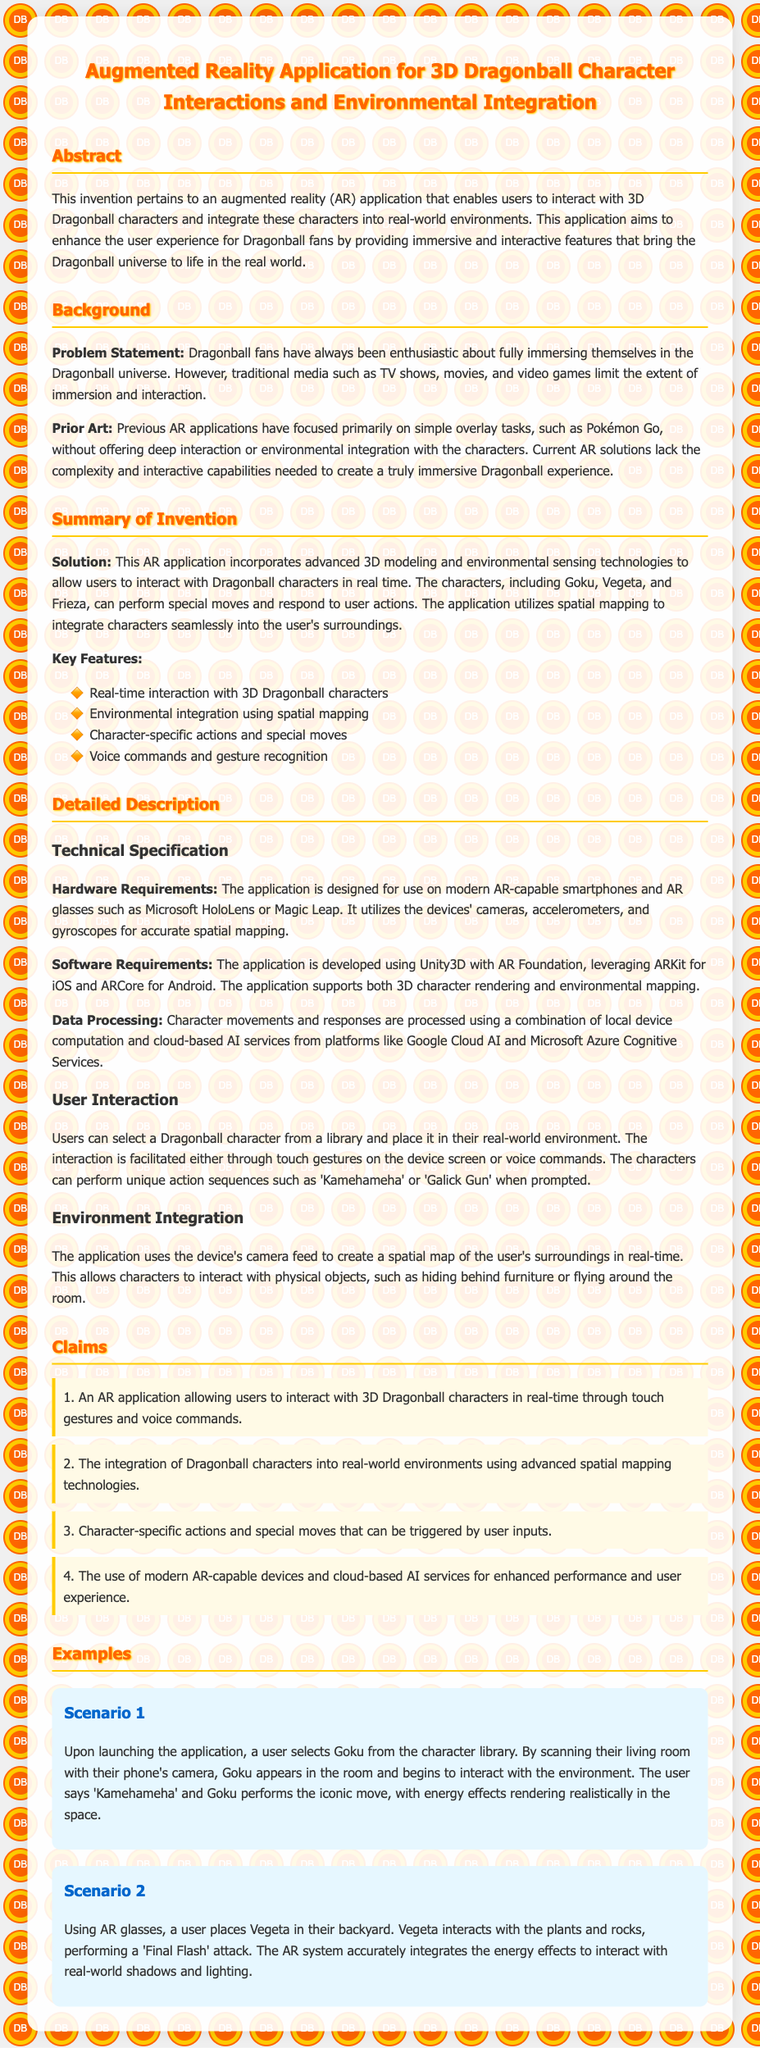What is the title of the patent application? The title of the patent application summarizing its purpose is prominently displayed at the top of the document.
Answer: Augmented Reality Application for 3D Dragonball Character Interactions and Environmental Integration Who are the characters mentioned in the summary of the invention? The summary lists specific Dragonball characters that users can interact with in the application, providing examples of known fan favorites.
Answer: Goku, Vegeta, Frieza What is the primary problem stated in the background section? The problem statement outlines the limitation of traditional media for Dragonball fans wanting immersive experiences.
Answer: Limited immersion and interaction Which technology is used for movement and responses processing? The document specifies the platforms utilized for processing character movements and responses, indicating the technological foundation of the application.
Answer: Cloud-based AI services What are the hardware requirements for the application? The hardware requirements section lists compatible devices necessary to run the application effectively.
Answer: AR-capable smartphones and AR glasses How can users interact with the characters? The user interaction section describes the different methods through which users can engage with Dragonball characters in the application.
Answer: Touch gestures and voice commands What is a unique action that characters can perform? The detailed description mentions specific actions that can be triggered during interactions, as examples of character abilities.
Answer: Kamehameha How does the application ensure environmental integration? The document explains how the application integrates characters into real-world settings, focusing on the technique employed for this purpose.
Answer: Spatial mapping What programming framework is used for the development of the application? The software requirements section specifies the framework utilized for developing the AR application, which is crucial for users developing similar projects.
Answer: Unity3D with AR Foundation 